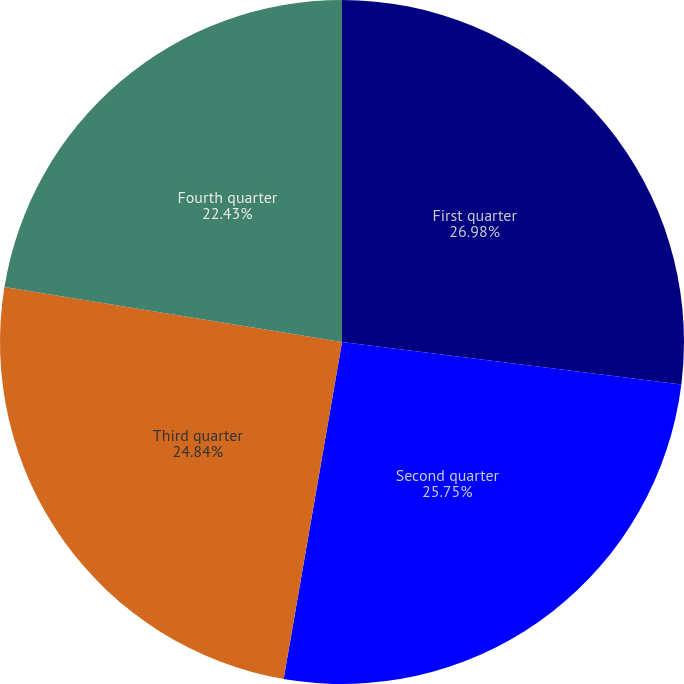Convert chart. <chart><loc_0><loc_0><loc_500><loc_500><pie_chart><fcel>First quarter<fcel>Second quarter<fcel>Third quarter<fcel>Fourth quarter<nl><fcel>26.98%<fcel>25.75%<fcel>24.84%<fcel>22.43%<nl></chart> 